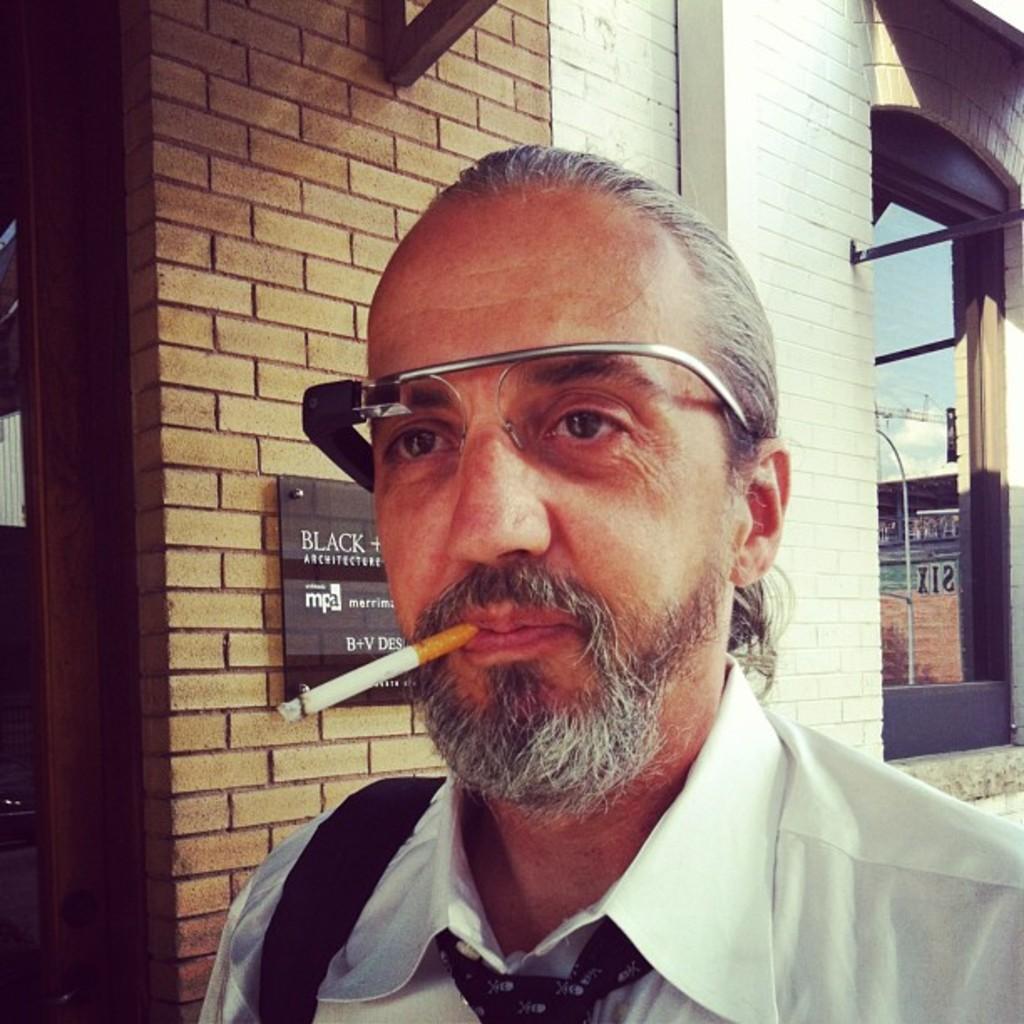Please provide a concise description of this image. In this image we can see a man wearing glasses is smoking a cigarette. In the background there is a board placed on the wall and we can see a building. 